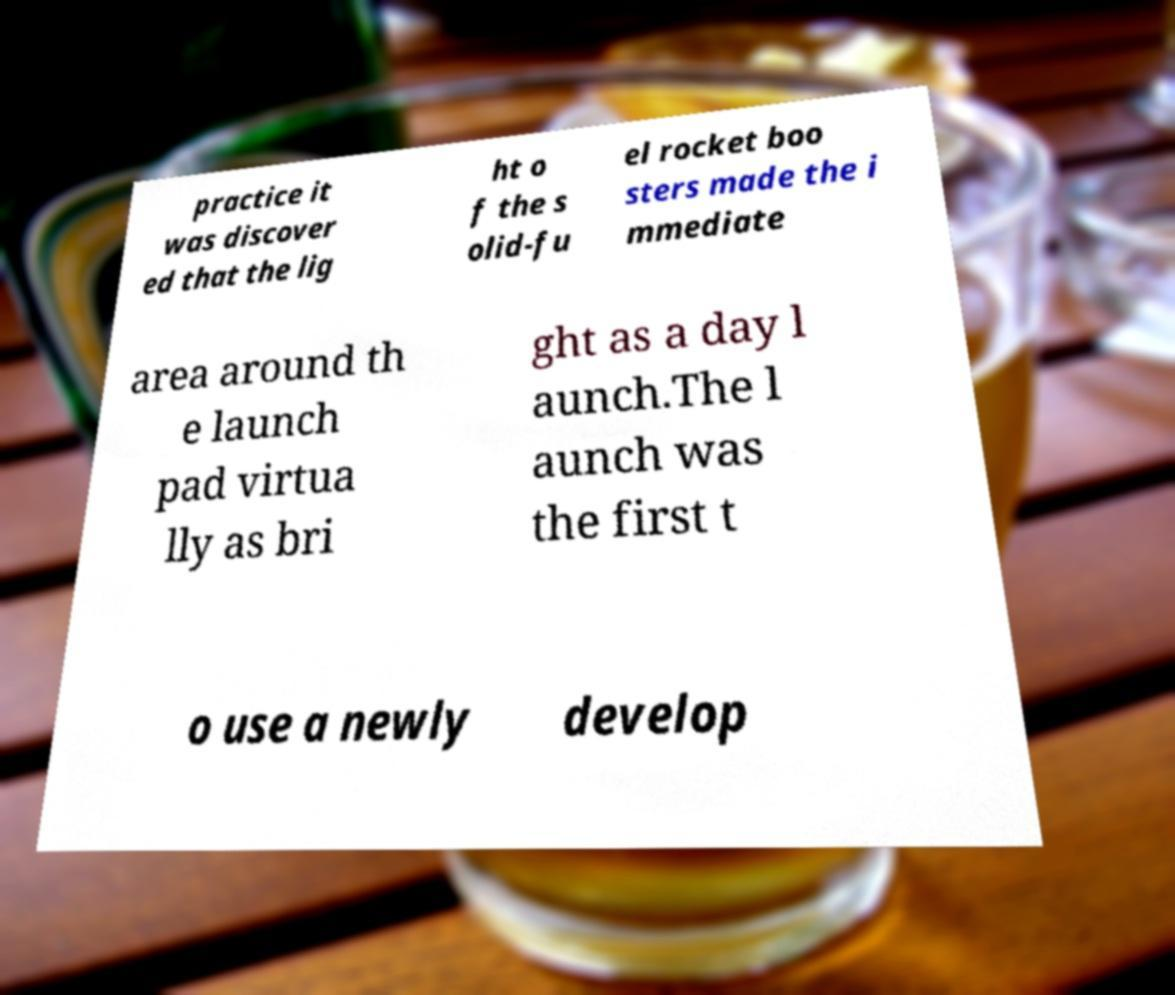For documentation purposes, I need the text within this image transcribed. Could you provide that? practice it was discover ed that the lig ht o f the s olid-fu el rocket boo sters made the i mmediate area around th e launch pad virtua lly as bri ght as a day l aunch.The l aunch was the first t o use a newly develop 